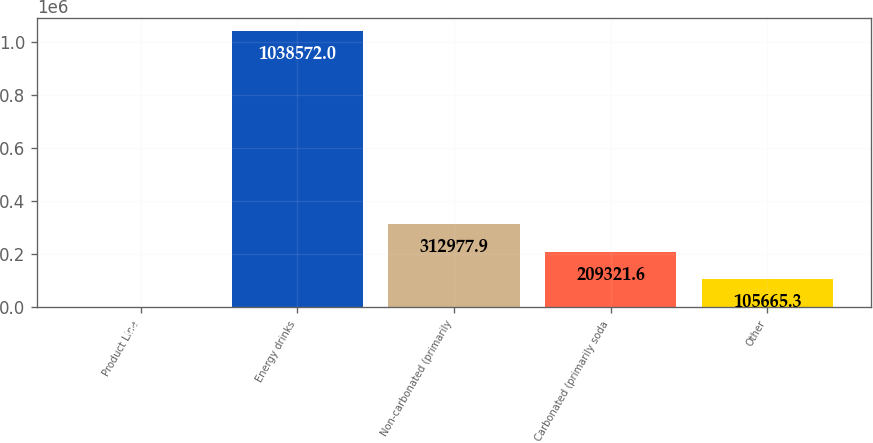Convert chart. <chart><loc_0><loc_0><loc_500><loc_500><bar_chart><fcel>Product Line<fcel>Energy drinks<fcel>Non-carbonated (primarily<fcel>Carbonated (primarily soda<fcel>Other<nl><fcel>2009<fcel>1.03857e+06<fcel>312978<fcel>209322<fcel>105665<nl></chart> 